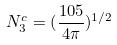Convert formula to latex. <formula><loc_0><loc_0><loc_500><loc_500>N _ { 3 } ^ { c } = ( \frac { 1 0 5 } { 4 \pi } ) ^ { 1 / 2 }</formula> 